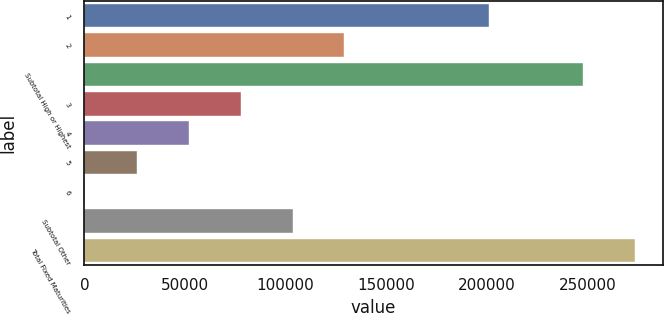Convert chart. <chart><loc_0><loc_0><loc_500><loc_500><bar_chart><fcel>1<fcel>2<fcel>Subtotal High or Highest<fcel>3<fcel>4<fcel>5<fcel>6<fcel>Subtotal Other<fcel>Total Fixed Maturities<nl><fcel>201273<fcel>129231<fcel>247916<fcel>77651.8<fcel>51862.2<fcel>26072.6<fcel>283<fcel>103441<fcel>273706<nl></chart> 